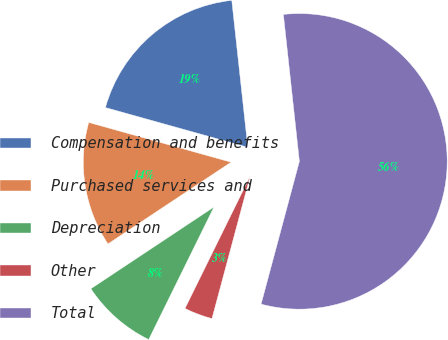<chart> <loc_0><loc_0><loc_500><loc_500><pie_chart><fcel>Compensation and benefits<fcel>Purchased services and<fcel>Depreciation<fcel>Other<fcel>Total<nl><fcel>18.94%<fcel>13.66%<fcel>8.39%<fcel>3.11%<fcel>55.9%<nl></chart> 